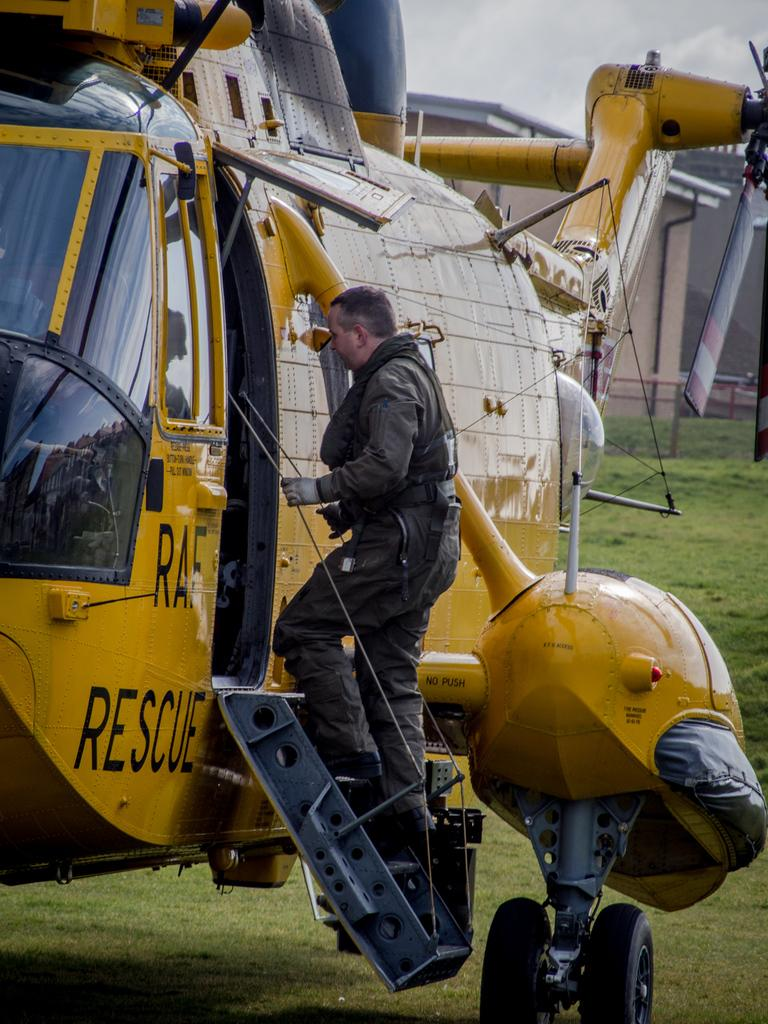<image>
Offer a succinct explanation of the picture presented. Man entering the RAF Rescue Helicopter, which is a yellow color. 